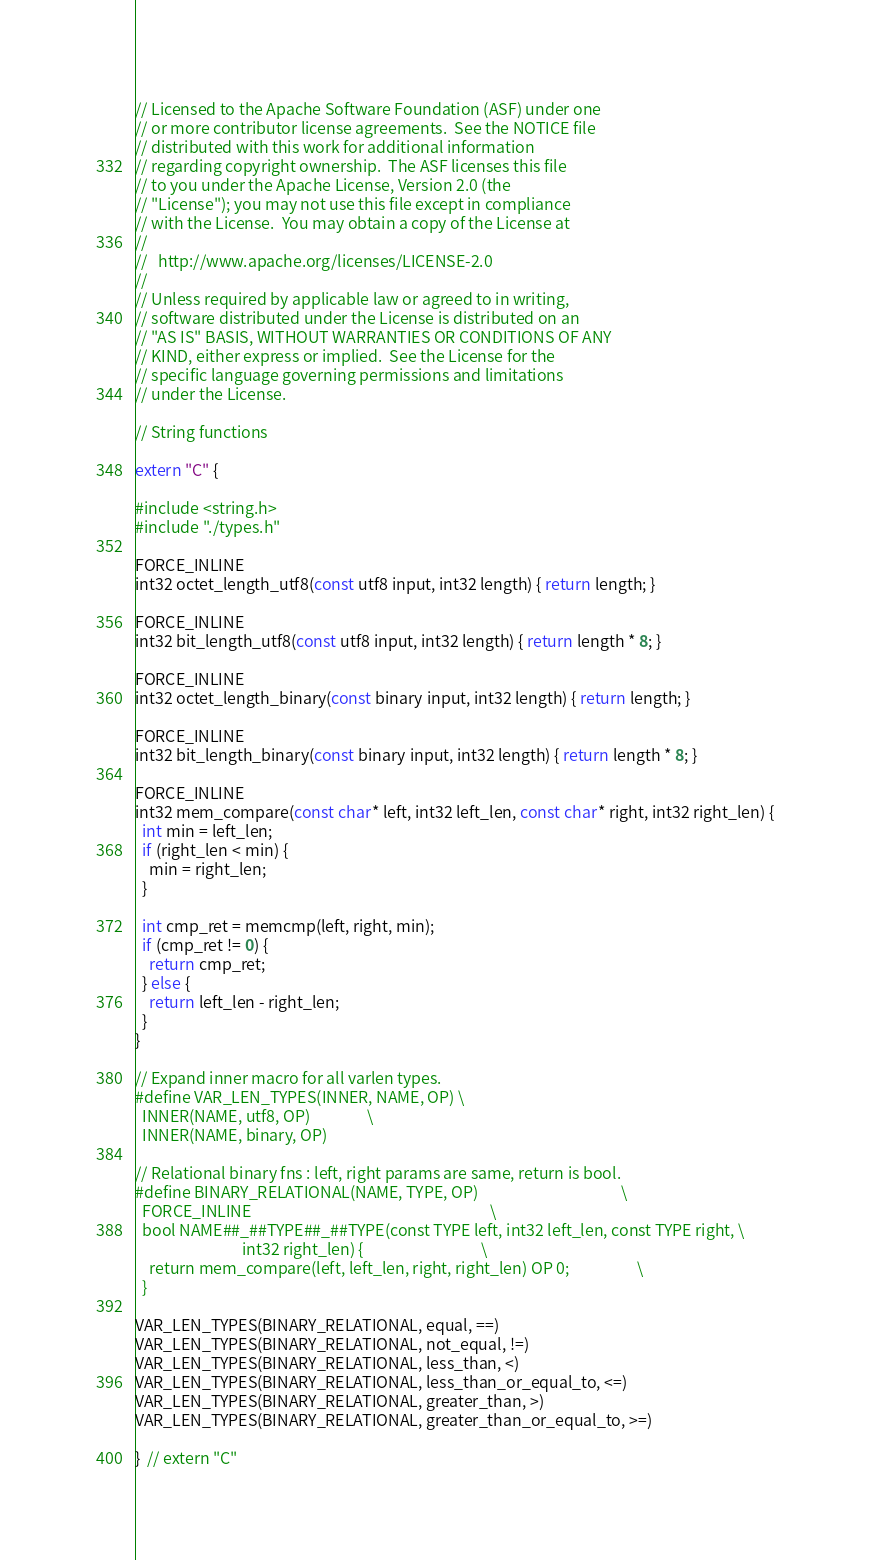Convert code to text. <code><loc_0><loc_0><loc_500><loc_500><_C++_>// Licensed to the Apache Software Foundation (ASF) under one
// or more contributor license agreements.  See the NOTICE file
// distributed with this work for additional information
// regarding copyright ownership.  The ASF licenses this file
// to you under the Apache License, Version 2.0 (the
// "License"); you may not use this file except in compliance
// with the License.  You may obtain a copy of the License at
//
//   http://www.apache.org/licenses/LICENSE-2.0
//
// Unless required by applicable law or agreed to in writing,
// software distributed under the License is distributed on an
// "AS IS" BASIS, WITHOUT WARRANTIES OR CONDITIONS OF ANY
// KIND, either express or implied.  See the License for the
// specific language governing permissions and limitations
// under the License.

// String functions

extern "C" {

#include <string.h>
#include "./types.h"

FORCE_INLINE
int32 octet_length_utf8(const utf8 input, int32 length) { return length; }

FORCE_INLINE
int32 bit_length_utf8(const utf8 input, int32 length) { return length * 8; }

FORCE_INLINE
int32 octet_length_binary(const binary input, int32 length) { return length; }

FORCE_INLINE
int32 bit_length_binary(const binary input, int32 length) { return length * 8; }

FORCE_INLINE
int32 mem_compare(const char* left, int32 left_len, const char* right, int32 right_len) {
  int min = left_len;
  if (right_len < min) {
    min = right_len;
  }

  int cmp_ret = memcmp(left, right, min);
  if (cmp_ret != 0) {
    return cmp_ret;
  } else {
    return left_len - right_len;
  }
}

// Expand inner macro for all varlen types.
#define VAR_LEN_TYPES(INNER, NAME, OP) \
  INNER(NAME, utf8, OP)                \
  INNER(NAME, binary, OP)

// Relational binary fns : left, right params are same, return is bool.
#define BINARY_RELATIONAL(NAME, TYPE, OP)                                        \
  FORCE_INLINE                                                                   \
  bool NAME##_##TYPE##_##TYPE(const TYPE left, int32 left_len, const TYPE right, \
                              int32 right_len) {                                 \
    return mem_compare(left, left_len, right, right_len) OP 0;                   \
  }

VAR_LEN_TYPES(BINARY_RELATIONAL, equal, ==)
VAR_LEN_TYPES(BINARY_RELATIONAL, not_equal, !=)
VAR_LEN_TYPES(BINARY_RELATIONAL, less_than, <)
VAR_LEN_TYPES(BINARY_RELATIONAL, less_than_or_equal_to, <=)
VAR_LEN_TYPES(BINARY_RELATIONAL, greater_than, >)
VAR_LEN_TYPES(BINARY_RELATIONAL, greater_than_or_equal_to, >=)

}  // extern "C"
</code> 